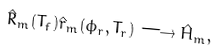Convert formula to latex. <formula><loc_0><loc_0><loc_500><loc_500>\hat { R } _ { m } ( T _ { f } ) \hat { r } _ { m } ( \phi _ { r } , T _ { r } ) \longrightarrow \hat { H } _ { m } ,</formula> 